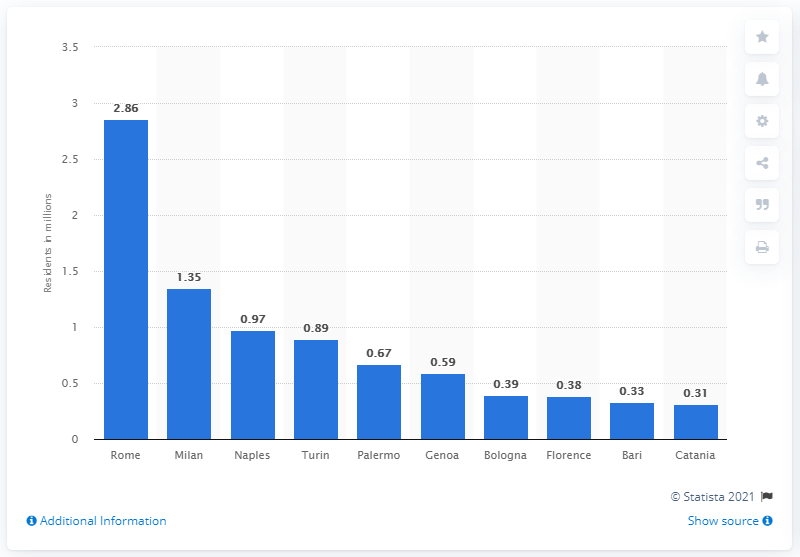Draw attention to some important aspects in this diagram. In 2015, it is estimated that approximately 2.86 people lived in Rome. 